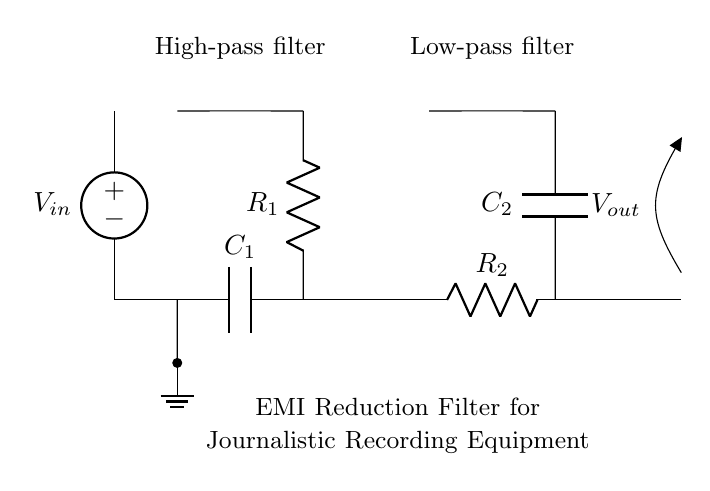What is the purpose of this circuit? The circuit is designed to reduce electromagnetic interference in recording equipment, ensuring clearer audio. This is evident from the label stating "EMI Reduction Filter for Journalistic Recording Equipment," indicating its specific function.
Answer: EMI Reduction Filter for Journalistic Recording Equipment What type of filters are used in this circuit? The circuit utilizes a high-pass filter and a low-pass filter, which are labeled accordingly in the diagram. The high-pass filter allows high-frequency signals to pass while blocking low-frequency interference, and the low-pass filter allows low-frequency signals to pass while blocking high frequencies.
Answer: High-pass and Low-pass filters What are the components of the high-pass filter? The high-pass filter consists of a capacitor labeled C1 and a resistor labeled R1. The capacitor and resistor in series create the high-pass characteristic of the filter. You can identify these components by their labels in the circuit diagram.
Answer: Capacitor C1 and Resistor R1 What is the output voltage notation in this circuit? The output voltage is denoted as "Vout" in the circuit diagram, clearly marked at the output side of the circuit near the symbol for voltage. This helps in identifying the point in the circuit where the filtered signal can be measured.
Answer: Vout What happens to low-frequency signals in this circuit? Low-frequency signals are mostly blocked by the high-pass filter, which is designed to prevent such frequencies from passing through. The response of the high-pass filter is indicated by its configuration with the capacitor and resistor, which effectively diminishes low-frequency elements from the output.
Answer: Blocked Which component is connected to ground in this circuit? The component connected to ground is at the bottom of the high-pass filter, paired with a short connection leading to the ground symbol. The ground connection forms a reference point for the entire circuit, crucial for proper functioning.
Answer: Short connection at the high-pass filter 